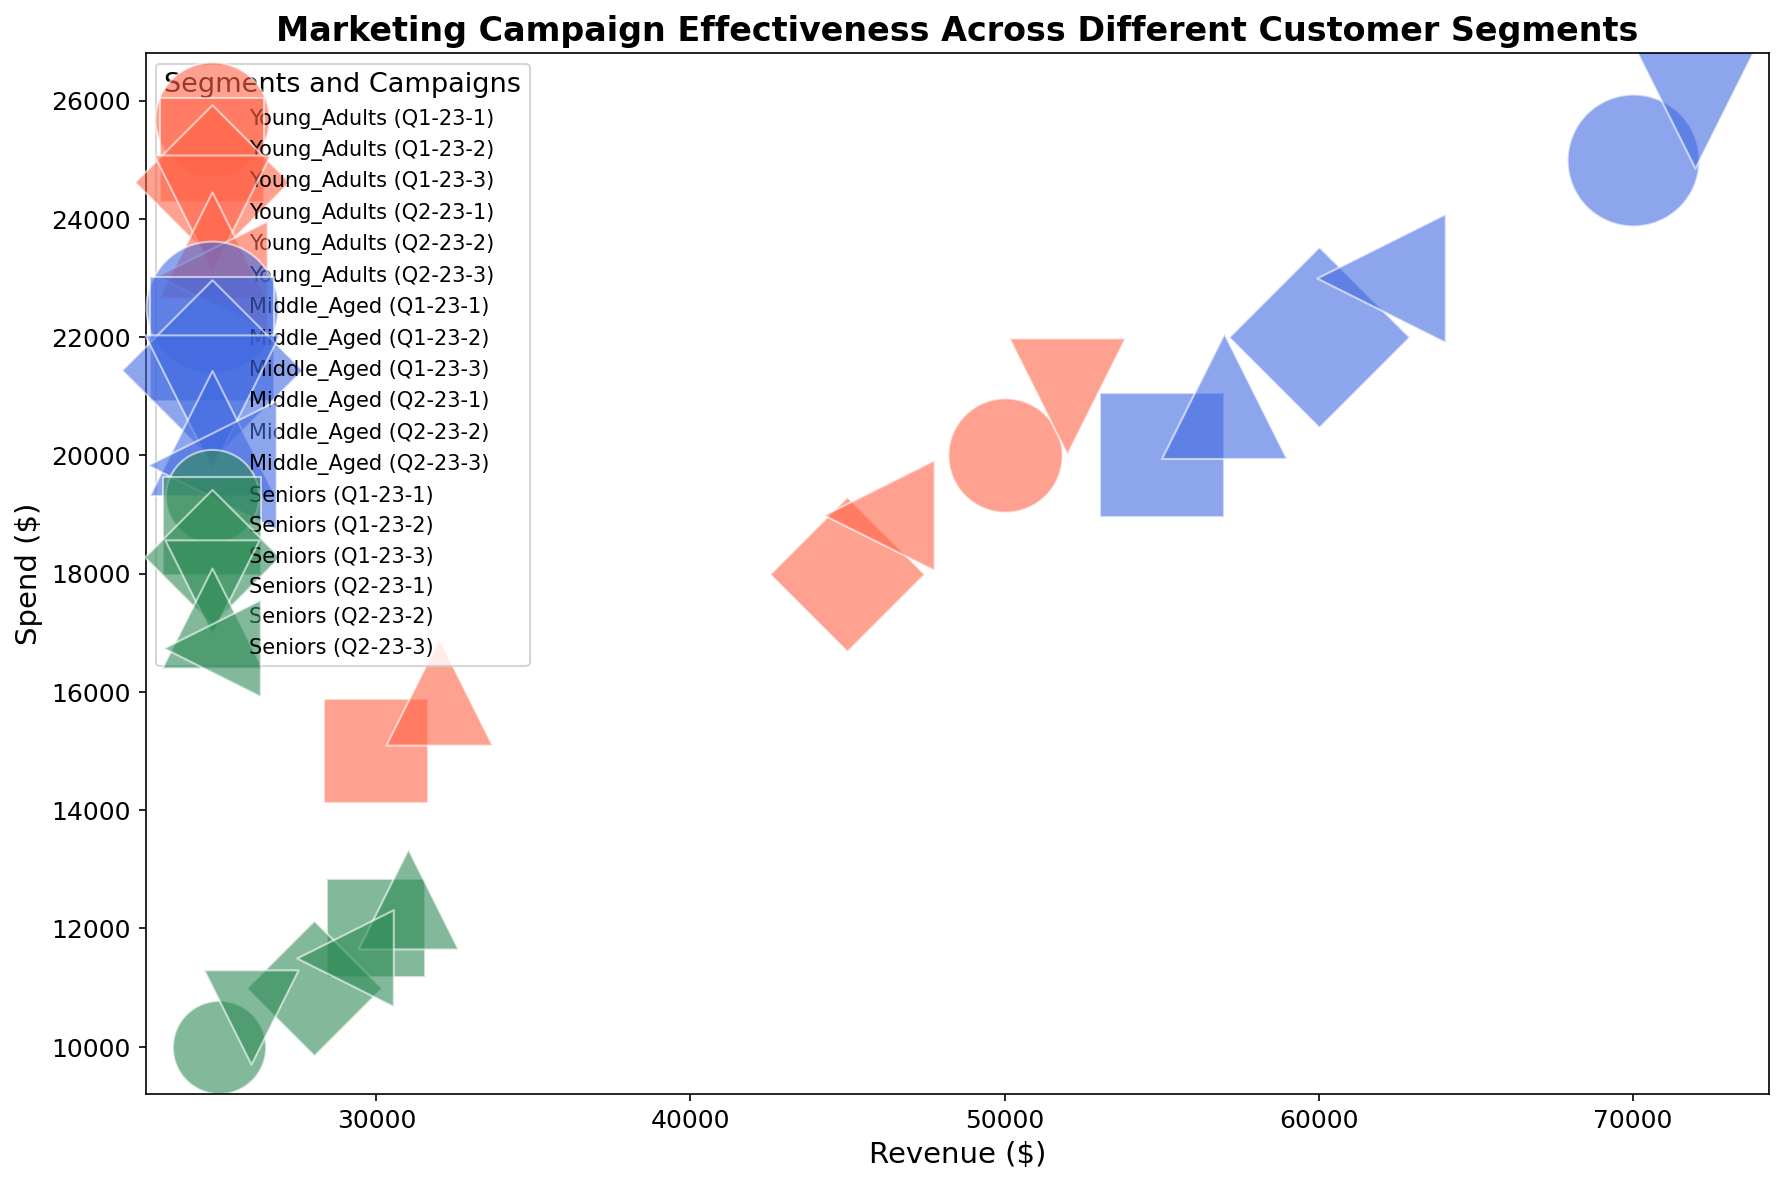Which customer segment spends the most on average? To find the average spend of each customer segment, add the spend amounts for each segment and divide by the number of campaigns. For Young_Adults: (20000+15000+18000+21000+16000+19000)/6 = 18166.67; for Middle_Aged: (25000+20000+22000+26000+21000+23000)/6 = 22833.33; for Seniors: (10000+12000+11000+10500+12500+11500)/6 = 11250. Middle_Aged has the highest average spend.
Answer: Middle_Aged Which campaign had the highest revenue for Young_Adults? Examine the scatter plot to find the campaign ID with the highest revenue for Young_Adults. The marker for the campaign Q1-23-1 has the highest position on the revenue axis among Young_Adults campaigns.
Answer: Q1-23-1 How does the spend for Middle_Aged in campaign Q2-23-1 compare to that of campaign Q1-23-1? Look at the markers representing Middle_Aged for campaigns Q2-23-1 and Q1-23-1. Both have different positions on the spend axis: Q2-23-1 at $26,000 and Q1-23-1 at $25,000. Hence, Q2-23-1 spends more.
Answer: Q2-23-1 spends more Which segment has the largest bubble size, and what does it represent? The largest bubble size indicates the highest customer count. By examining the bubble sizes visually, Middle_Aged has the largest bubbles, representing the highest number of customers in their campaigns.
Answer: Middle_Aged What is the relationship between spend and revenue for campaign Q2-23-2 across different segments? Locate Q2-23-2 markers in the scatter plot: for Young_Adults ($16,000 spend, $32,000 revenue), for Middle_Aged ($21,000 spend, $57,000 revenue), and for Seniors ($12,500 spend, $31,000 revenue). Both revenue and spend for Middle_Aged are higher than Young_Adults and Seniors.
Answer: Positive relationship; higher spend results in higher revenue in Middle_Aged Which segment and campaign combination had the lowest revenue, and what was the spend? Identify the lowest position on the revenue axis across all segments and campaigns, which corresponds to Seniors in Q1-23-1 with $25,000 revenue. The spend in this campaign is $10,000.
Answer: Seniors, Q1-23-1, $10,000 spend Are there any campaigns where the spend was higher but revenue was lower within the same segment? Compare spend and revenue for campaigns within each segment. In Young_Adults, Q1-23-2 (spend: $15,000, revenue: $30,000) and Q2-23-2 (spend: $16,000, revenue: $32,000), spend is higher but revenue is lower compared to Q1-23-1 (spend: $20,000, revenue: $50,000).
Answer: Yes, Q1-23-2 and Q2-23-2 in Young_Adults What was the most effective campaign for Seniors in terms of revenue per dollar spent? Calculate the revenue per dollar spent for each campaign in Seniors. Q1-23-1: $25,000/$10,000 = 2.5; Q1-23-2: $30,000/$12,000 = 2.5; Q1-23-3: $28,000/$11,000 = 2.55; Q2-23-1: $26,000/$10,500 = 2.48; Q2-23-2: $31,000/$12,500 = 2.48; Q2-23-3: $29,000/$11,500 = 2.52. Q1-23-3 has the highest ratio.
Answer: Q1-23-3 How does the revenue trend compare between Q1 and Q2 for Middle_Aged groups? Examine revenue points for Middle_Aged in Q1 campaigns (Q1-23-1: $70,000, Q1-23-2: $55,000, Q1-23-3: $60,000) and Q2 campaigns (Q2-23-1: $72,000, Q2-23-2: $57,000, Q2-23-3: $62,000). The trend shows an increase in Q2 compared to Q1.
Answer: Increasing trend in Q2 